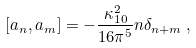<formula> <loc_0><loc_0><loc_500><loc_500>[ a _ { n } , a _ { m } ] = - \frac { \kappa _ { 1 0 } ^ { 2 } } { 1 6 \pi ^ { 5 } } n \delta _ { n + m } \, ,</formula> 